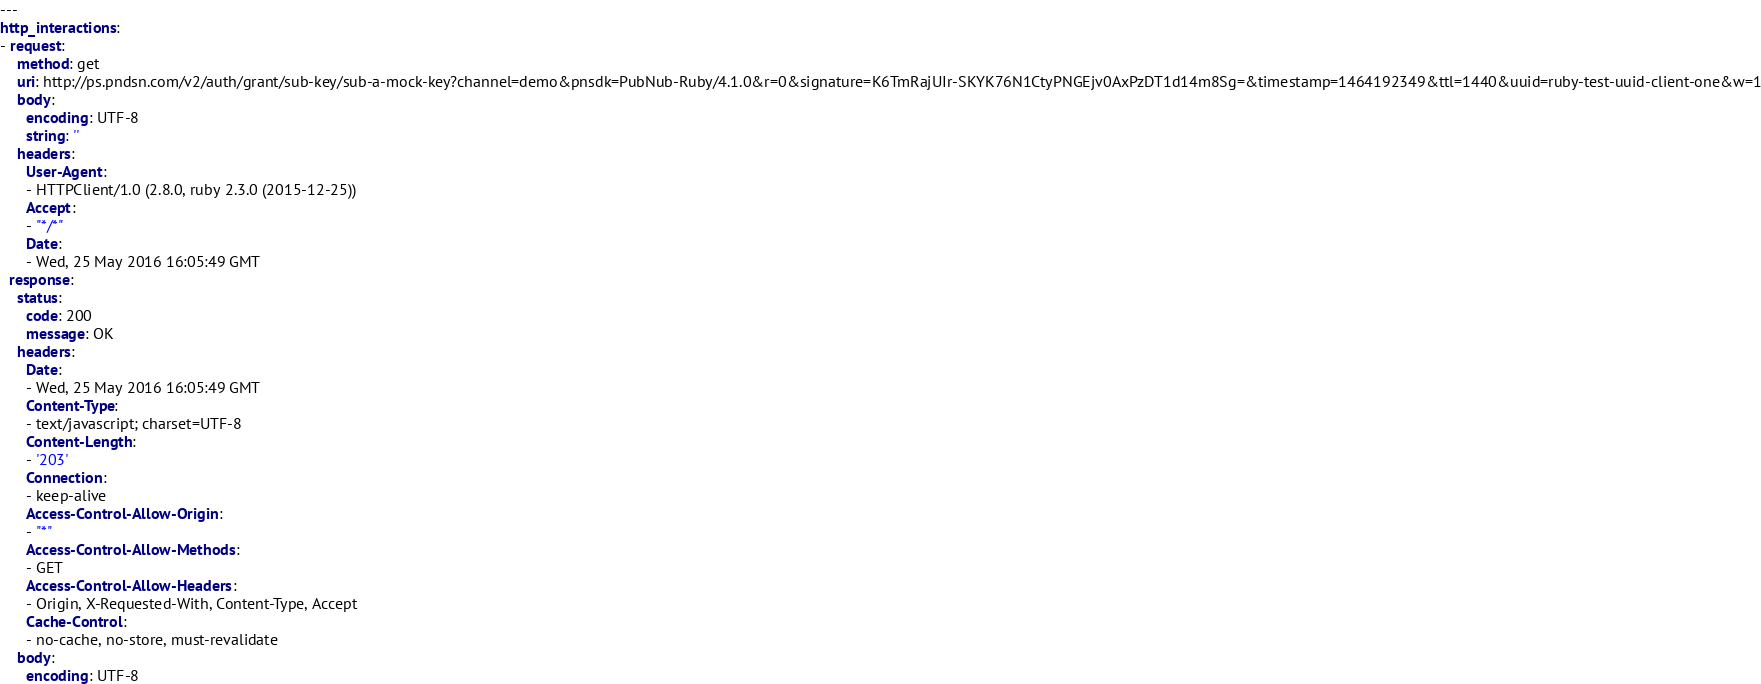<code> <loc_0><loc_0><loc_500><loc_500><_YAML_>---
http_interactions:
- request:
    method: get
    uri: http://ps.pndsn.com/v2/auth/grant/sub-key/sub-a-mock-key?channel=demo&pnsdk=PubNub-Ruby/4.1.0&r=0&signature=K6TmRajUIr-SKYK76N1CtyPNGEjv0AxPzDT1d14m8Sg=&timestamp=1464192349&ttl=1440&uuid=ruby-test-uuid-client-one&w=1
    body:
      encoding: UTF-8
      string: ''
    headers:
      User-Agent:
      - HTTPClient/1.0 (2.8.0, ruby 2.3.0 (2015-12-25))
      Accept:
      - "*/*"
      Date:
      - Wed, 25 May 2016 16:05:49 GMT
  response:
    status:
      code: 200
      message: OK
    headers:
      Date:
      - Wed, 25 May 2016 16:05:49 GMT
      Content-Type:
      - text/javascript; charset=UTF-8
      Content-Length:
      - '203'
      Connection:
      - keep-alive
      Access-Control-Allow-Origin:
      - "*"
      Access-Control-Allow-Methods:
      - GET
      Access-Control-Allow-Headers:
      - Origin, X-Requested-With, Content-Type, Accept
      Cache-Control:
      - no-cache, no-store, must-revalidate
    body:
      encoding: UTF-8</code> 